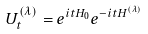Convert formula to latex. <formula><loc_0><loc_0><loc_500><loc_500>U ^ { ( \lambda ) } _ { t } = e ^ { i t H _ { 0 } } e ^ { - i t H ^ { ( \lambda ) } }</formula> 